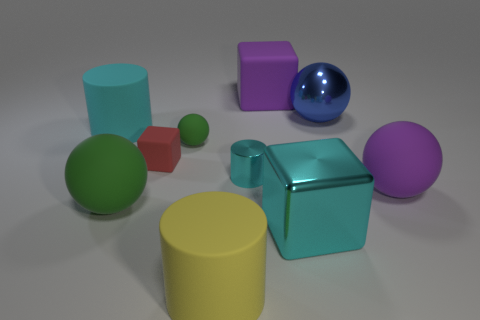Subtract all cubes. How many objects are left? 7 Add 2 big purple matte cubes. How many big purple matte cubes are left? 3 Add 5 small blue cylinders. How many small blue cylinders exist? 5 Subtract 0 blue cylinders. How many objects are left? 10 Subtract all red things. Subtract all metal balls. How many objects are left? 8 